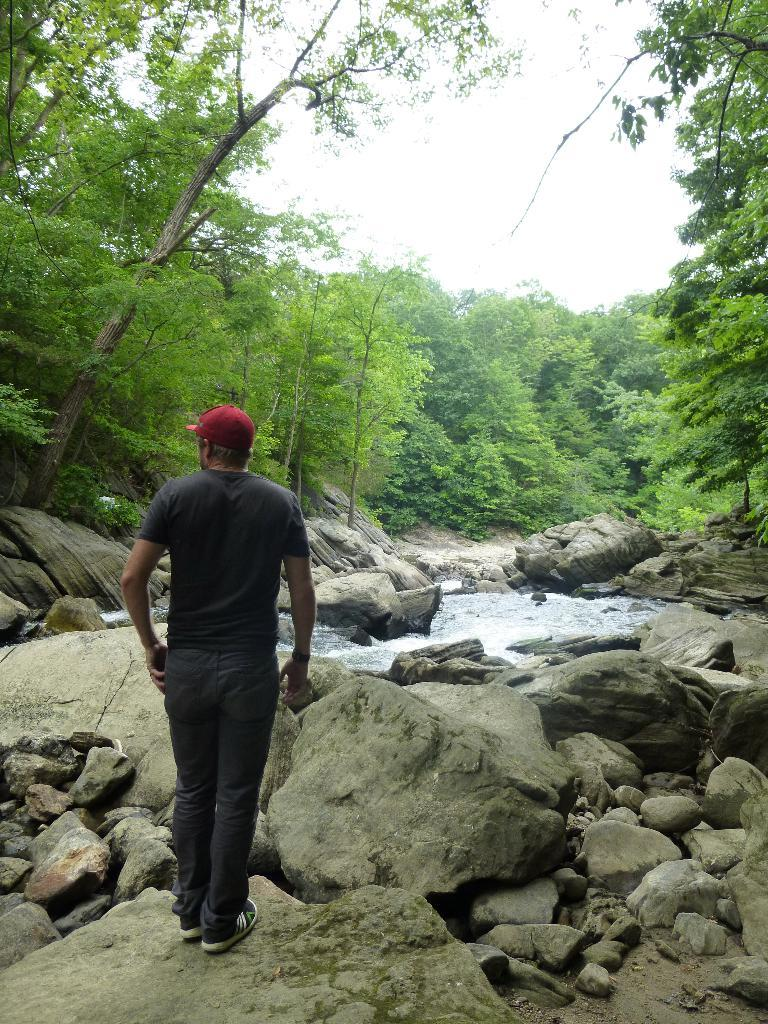What is the man in the image doing? The man is standing in the image. What is the man wearing on his head? The man is wearing a cap. What type of natural elements can be seen in the image? There are stones, rocks, and water visible in the image. What can be seen in the background of the image? There are trees and the sky visible in the background of the image. Can you tell me how many cribs are in the image? There are no cribs present in the image. How does the man help the trees in the image? The man is not shown helping the trees in the image; he is simply standing. 